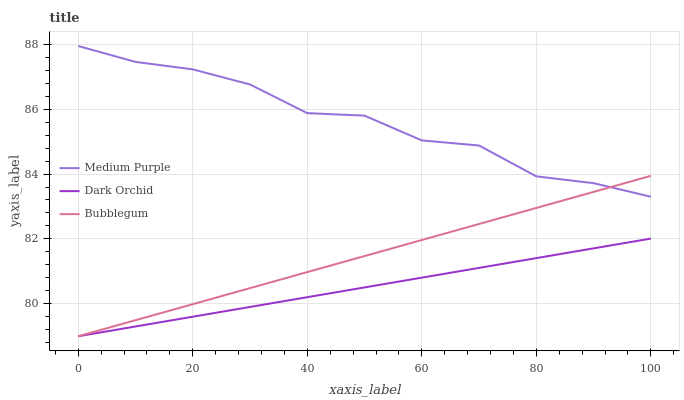Does Dark Orchid have the minimum area under the curve?
Answer yes or no. Yes. Does Medium Purple have the maximum area under the curve?
Answer yes or no. Yes. Does Bubblegum have the minimum area under the curve?
Answer yes or no. No. Does Bubblegum have the maximum area under the curve?
Answer yes or no. No. Is Dark Orchid the smoothest?
Answer yes or no. Yes. Is Medium Purple the roughest?
Answer yes or no. Yes. Is Bubblegum the smoothest?
Answer yes or no. No. Is Bubblegum the roughest?
Answer yes or no. No. Does Medium Purple have the highest value?
Answer yes or no. Yes. Does Bubblegum have the highest value?
Answer yes or no. No. Is Dark Orchid less than Medium Purple?
Answer yes or no. Yes. Is Medium Purple greater than Dark Orchid?
Answer yes or no. Yes. Does Bubblegum intersect Medium Purple?
Answer yes or no. Yes. Is Bubblegum less than Medium Purple?
Answer yes or no. No. Is Bubblegum greater than Medium Purple?
Answer yes or no. No. Does Dark Orchid intersect Medium Purple?
Answer yes or no. No. 